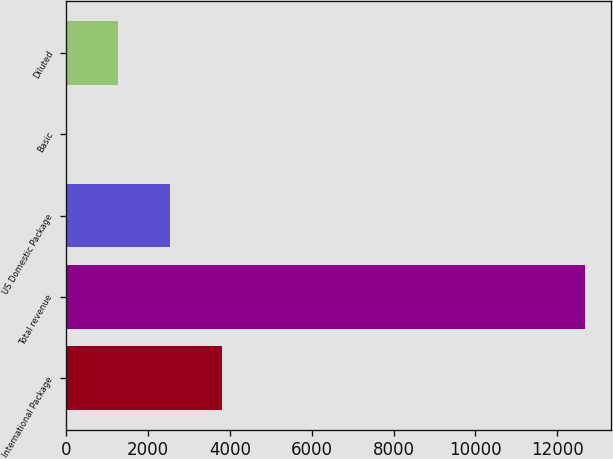Convert chart. <chart><loc_0><loc_0><loc_500><loc_500><bar_chart><fcel>International Package<fcel>Total revenue<fcel>US Domestic Package<fcel>Basic<fcel>Diluted<nl><fcel>3803.1<fcel>12675<fcel>2535.69<fcel>0.87<fcel>1268.28<nl></chart> 